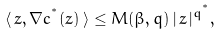Convert formula to latex. <formula><loc_0><loc_0><loc_500><loc_500>\langle \, z , \nabla c ^ { ^ { * } } ( z ) \, \rangle \leq M ( \beta , q ) \, | \, z \, | ^ { q ^ { ^ { * } } } ,</formula> 